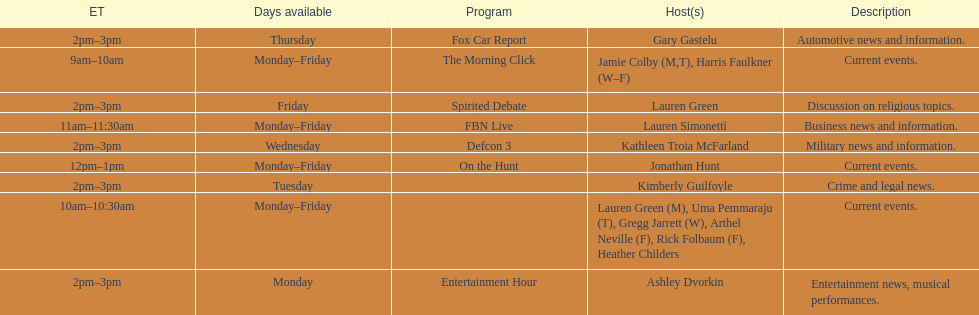How long does the show defcon 3 last? 1 hour. 